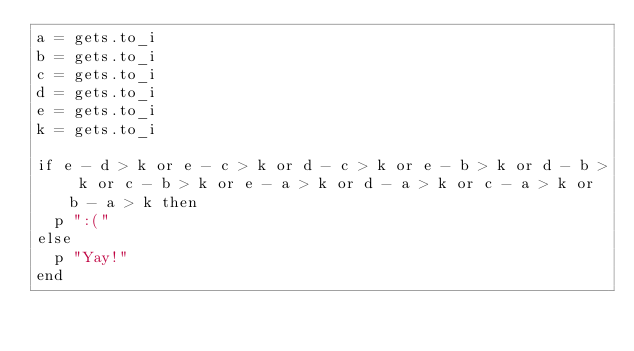Convert code to text. <code><loc_0><loc_0><loc_500><loc_500><_Ruby_>a = gets.to_i
b = gets.to_i
c = gets.to_i
d = gets.to_i
e = gets.to_i
k = gets.to_i

if e - d > k or e - c > k or d - c > k or e - b > k or d - b > k or c - b > k or e - a > k or d - a > k or c - a > k or b - a > k then
  p ":("
else
  p "Yay!"
end
</code> 